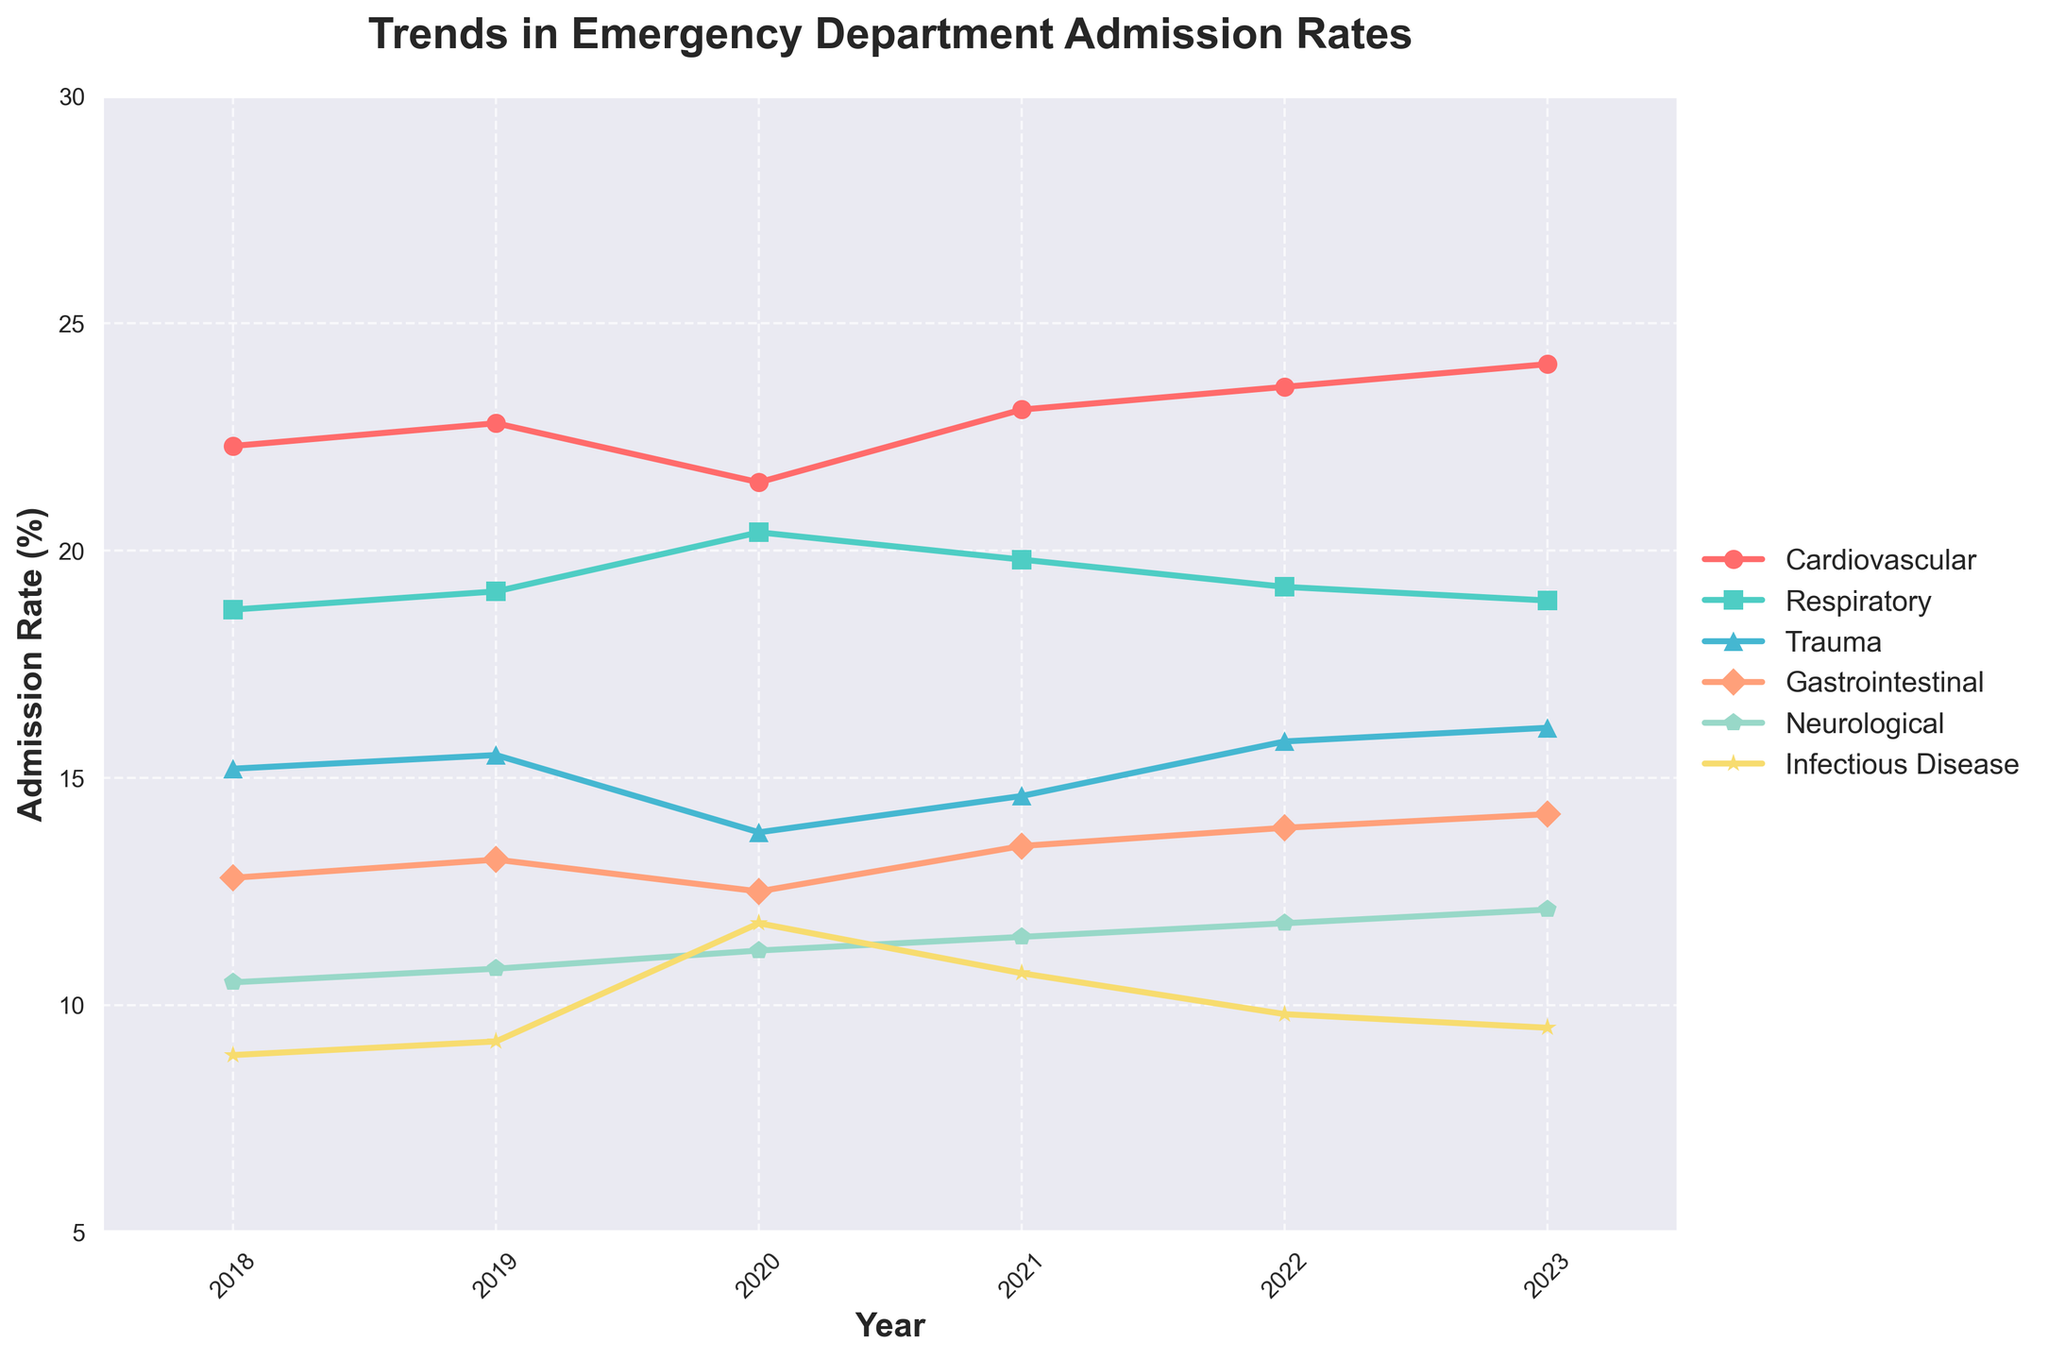What is the overall trend for Cardiovascular admission rates from 2018 to 2023? Look at the line representing Cardiovascular data points; it shows an increasing trend over the years from 22.3% in 2018 to 24.1% in 2023.
Answer: Increasing Which diagnosis group saw the most significant increase in admission rates from 2020 to 2023? Compare the admission rates for all groups between 2020 and 2023: Cardiovascular (21.5 to 24.1), Respiratory (20.4 to 18.9), Trauma (13.8 to 16.1), Gastrointestinal (12.5 to 14.2), Neurological (11.2 to 12.1), Infectious Disease (11.8 to 9.5). Trauma had the most significant increase (13.8 to 16.1).
Answer: Trauma Which group had the highest admission rate in 2023? Look at the data points for 2023 and compare the values for each group. Cardiovascular had the highest admission rate at 24.1%.
Answer: Cardiovascular How did the admission rates for Respiratory-related cases change from 2020 to 2023? Check the data points for Respiratory from 2020 (20.4%) to 2023 (18.9%); identify it decreased by 1.5 percentage points.
Answer: Decreased Compare the admission rate change for Infectious Disease from 2018 to 2023 with that for Neurological cases over the same period. Infectious Disease reduced from 8.9 to 9.5, a decrease of 0.6. Neurological increased from 10.5 to 12.1, an increase of 1.6.
Answer: Infectious Disease decreased by 0.6 and Neurological increased by 1.6 What was the average admission rate for Gastrointestinal cases over the 5 years? Calculate the average of the Gastrointestinal rates from 2018 to 2023: (12.8 + 13.2 + 12.5 + 13.5 + 13.9 + 14.2)/6 = 80.1/6 = 13.35.
Answer: 13.35 Which year saw the highest admission rate for Respiratory cases? Refer to the data points for Respiratory across all years and identify that 2020 had the highest rate at 20.4%.
Answer: 2020 What is the total change in admission rate for Trauma cases between 2018 and 2023? Subtract the 2018 rate (15.2) from the 2023 rate (16.1) to find the change, which is 0.9.
Answer: 0.9 Which diagnosis group's rate remained relatively stable throughout the 5 years? Look at the lines for each diagnosis group and observe that Gastrointestinal remained the most stable, with values between 12.5 and 14.2.
Answer: Gastrointestinal 